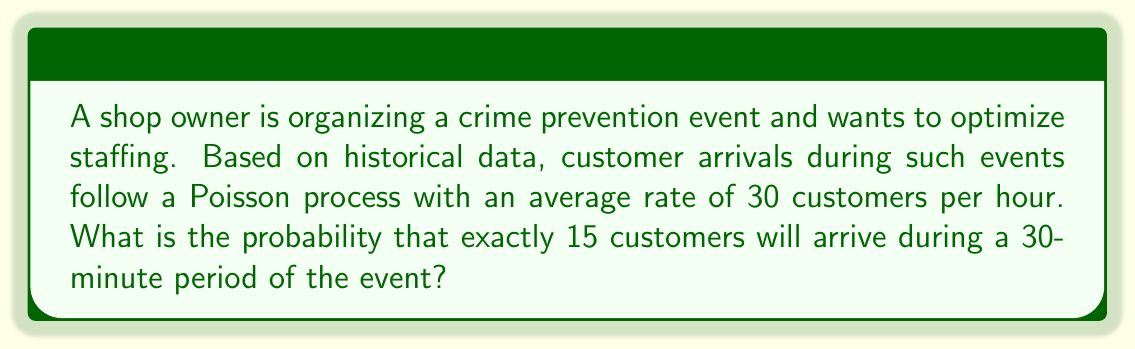Provide a solution to this math problem. To solve this problem, we'll use the Poisson distribution formula. The Poisson distribution is given by:

$$P(X = k) = \frac{e^{-\lambda} \lambda^k}{k!}$$

Where:
- $\lambda$ is the average number of events in the given time interval
- $k$ is the number of events we're interested in
- $e$ is Euler's number (approximately 2.71828)

Steps:
1. Calculate $\lambda$ for a 30-minute period:
   $\lambda = 30 \text{ customers/hour} \times 0.5 \text{ hours} = 15 \text{ customers}$

2. Set $k = 15$ (we want exactly 15 customers)

3. Plug these values into the Poisson formula:

   $$P(X = 15) = \frac{e^{-15} 15^{15}}{15!}$$

4. Calculate using a calculator or computer:
   
   $$P(X = 15) \approx 0.1014$$

5. Convert to a percentage:
   $0.1014 \times 100\% = 10.14\%$
Answer: 10.14% 